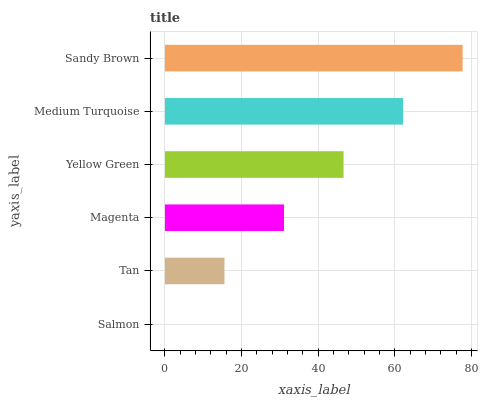Is Salmon the minimum?
Answer yes or no. Yes. Is Sandy Brown the maximum?
Answer yes or no. Yes. Is Tan the minimum?
Answer yes or no. No. Is Tan the maximum?
Answer yes or no. No. Is Tan greater than Salmon?
Answer yes or no. Yes. Is Salmon less than Tan?
Answer yes or no. Yes. Is Salmon greater than Tan?
Answer yes or no. No. Is Tan less than Salmon?
Answer yes or no. No. Is Yellow Green the high median?
Answer yes or no. Yes. Is Magenta the low median?
Answer yes or no. Yes. Is Magenta the high median?
Answer yes or no. No. Is Salmon the low median?
Answer yes or no. No. 